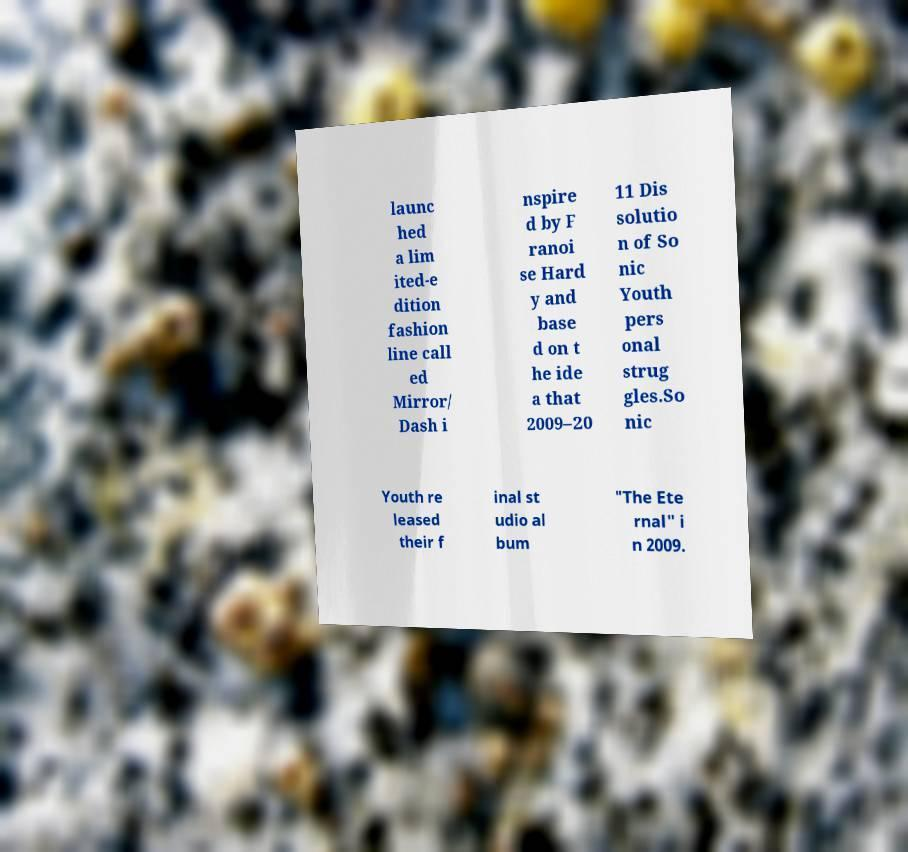What messages or text are displayed in this image? I need them in a readable, typed format. launc hed a lim ited-e dition fashion line call ed Mirror/ Dash i nspire d by F ranoi se Hard y and base d on t he ide a that 2009–20 11 Dis solutio n of So nic Youth pers onal strug gles.So nic Youth re leased their f inal st udio al bum "The Ete rnal" i n 2009. 